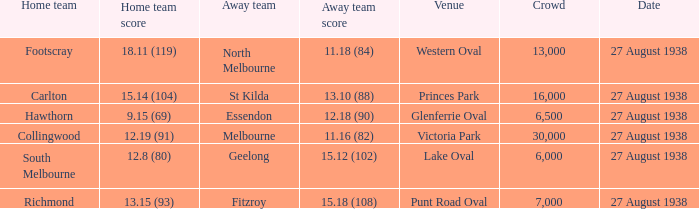I'm looking to parse the entire table for insights. Could you assist me with that? {'header': ['Home team', 'Home team score', 'Away team', 'Away team score', 'Venue', 'Crowd', 'Date'], 'rows': [['Footscray', '18.11 (119)', 'North Melbourne', '11.18 (84)', 'Western Oval', '13,000', '27 August 1938'], ['Carlton', '15.14 (104)', 'St Kilda', '13.10 (88)', 'Princes Park', '16,000', '27 August 1938'], ['Hawthorn', '9.15 (69)', 'Essendon', '12.18 (90)', 'Glenferrie Oval', '6,500', '27 August 1938'], ['Collingwood', '12.19 (91)', 'Melbourne', '11.16 (82)', 'Victoria Park', '30,000', '27 August 1938'], ['South Melbourne', '12.8 (80)', 'Geelong', '15.12 (102)', 'Lake Oval', '6,000', '27 August 1938'], ['Richmond', '13.15 (93)', 'Fitzroy', '15.18 (108)', 'Punt Road Oval', '7,000', '27 August 1938']]} Which home team had the away team score 15.18 (108) against them? 13.15 (93). 